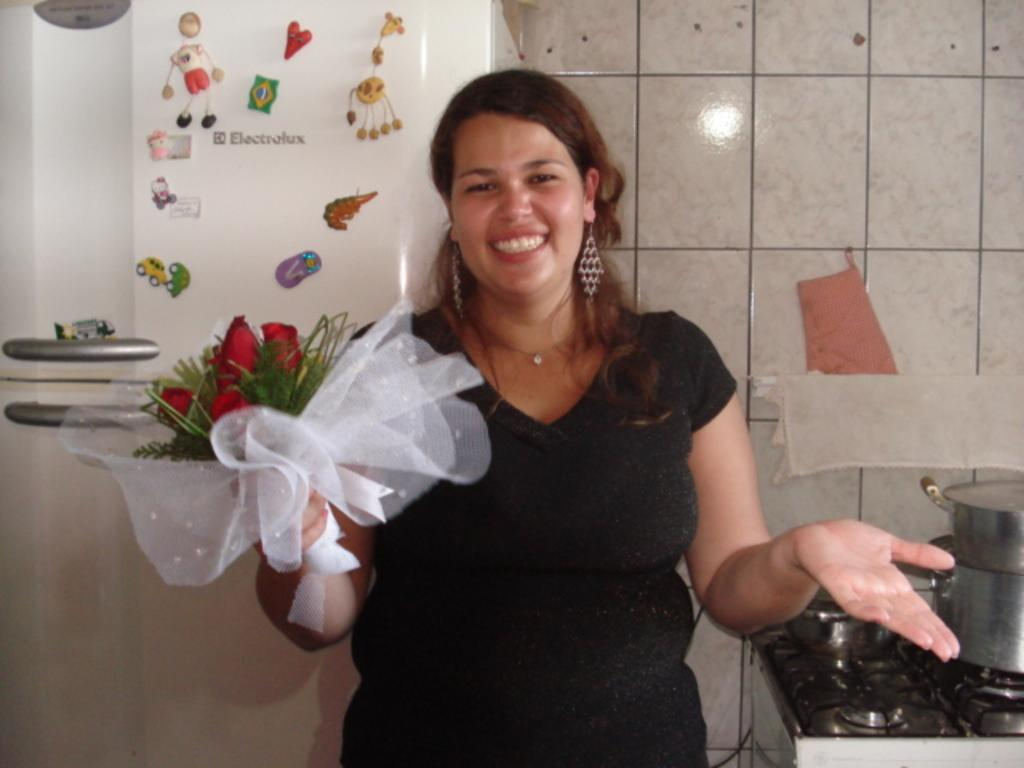What is the woman holding in the image? The woman is holding a bouquet. What can be seen in the background of the image? There is a wall in the image. What kitchen appliance is visible in the image? There is a stove with utensils on it in the image. What other kitchen appliance can be seen in the image? There is a refrigerator in the image. How many brothers are visible in the image? There are no brothers present in the image. What type of finger can be seen holding the bouquet in the image? There is no finger holding the bouquet in the image; the woman is holding it with her hand. 